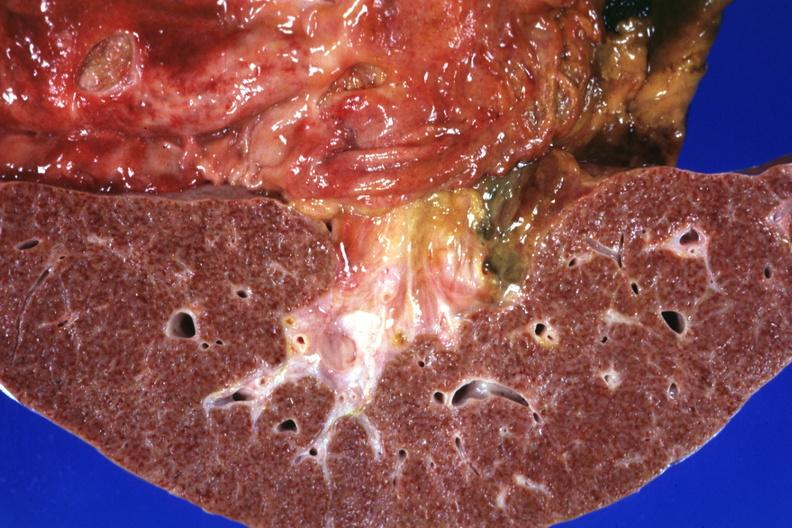what is present?
Answer the question using a single word or phrase. Liver 